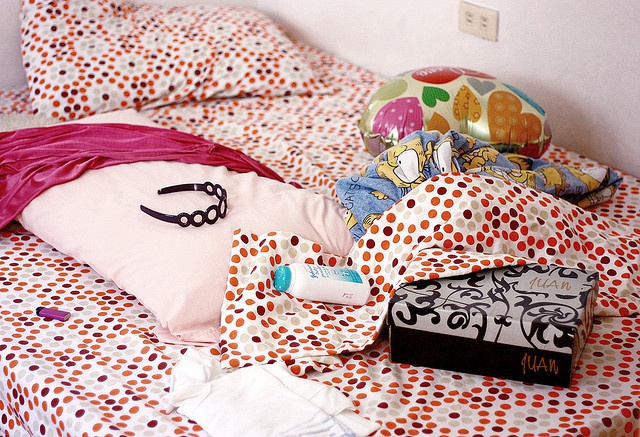Describe the objects in this image and their specific colors. I can see bed in lightgray, lightpink, darkgray, and brown tones and bottle in lightgray, teal, lightblue, and pink tones in this image. 